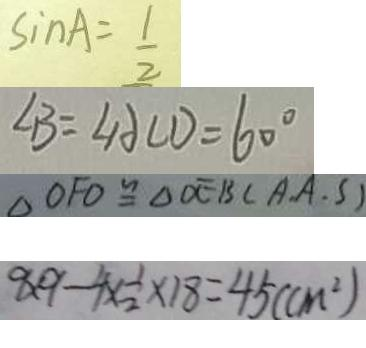Convert formula to latex. <formula><loc_0><loc_0><loc_500><loc_500>\sin A = \frac { 1 } { 2 } 
 \angle B = \angle A C D = 6 0 ^ { \circ } 
 \Delta O F O \cong \Delta D E B ( A . A . S ) 
 9 \times 9 - 4 \times \frac { 1 } { 2 } \times 1 8 = 4 5 ( c m ^ { 2 } )</formula> 